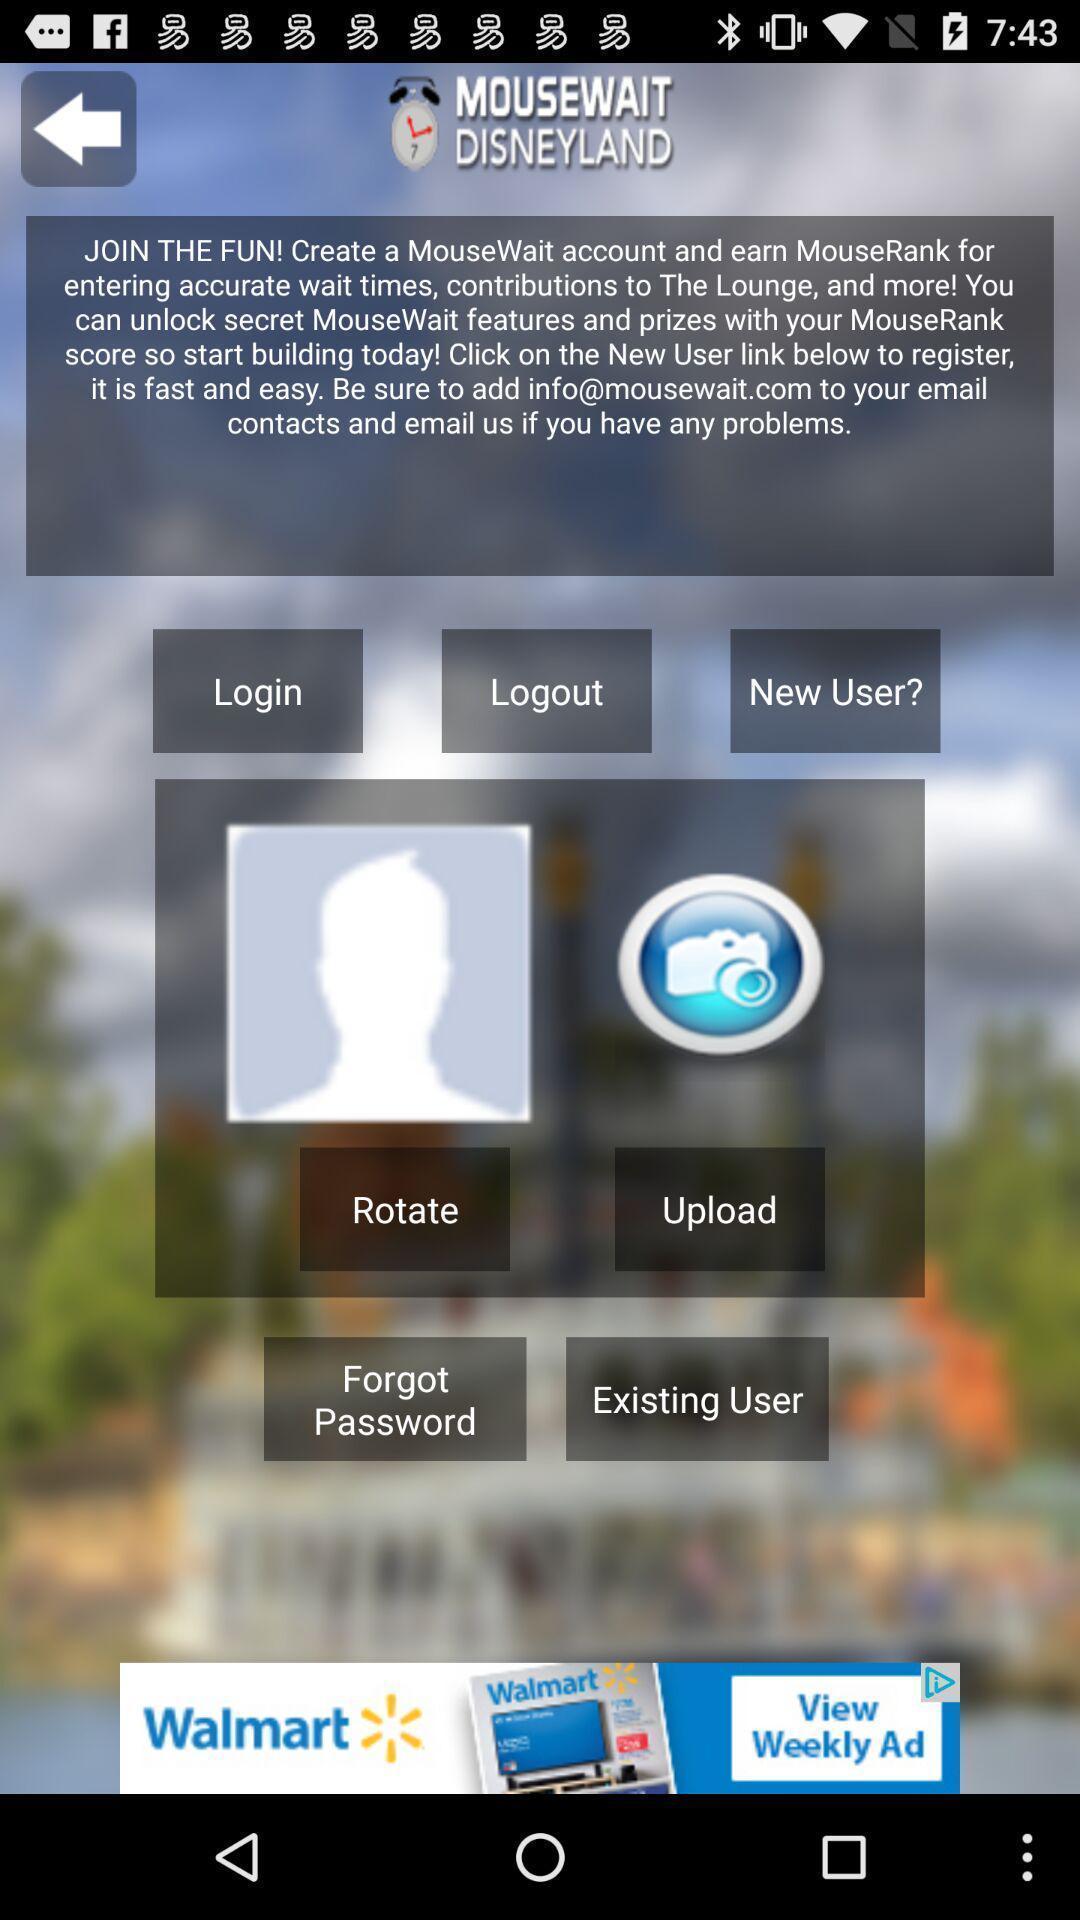What is the overall content of this screenshot? Welcome page. 